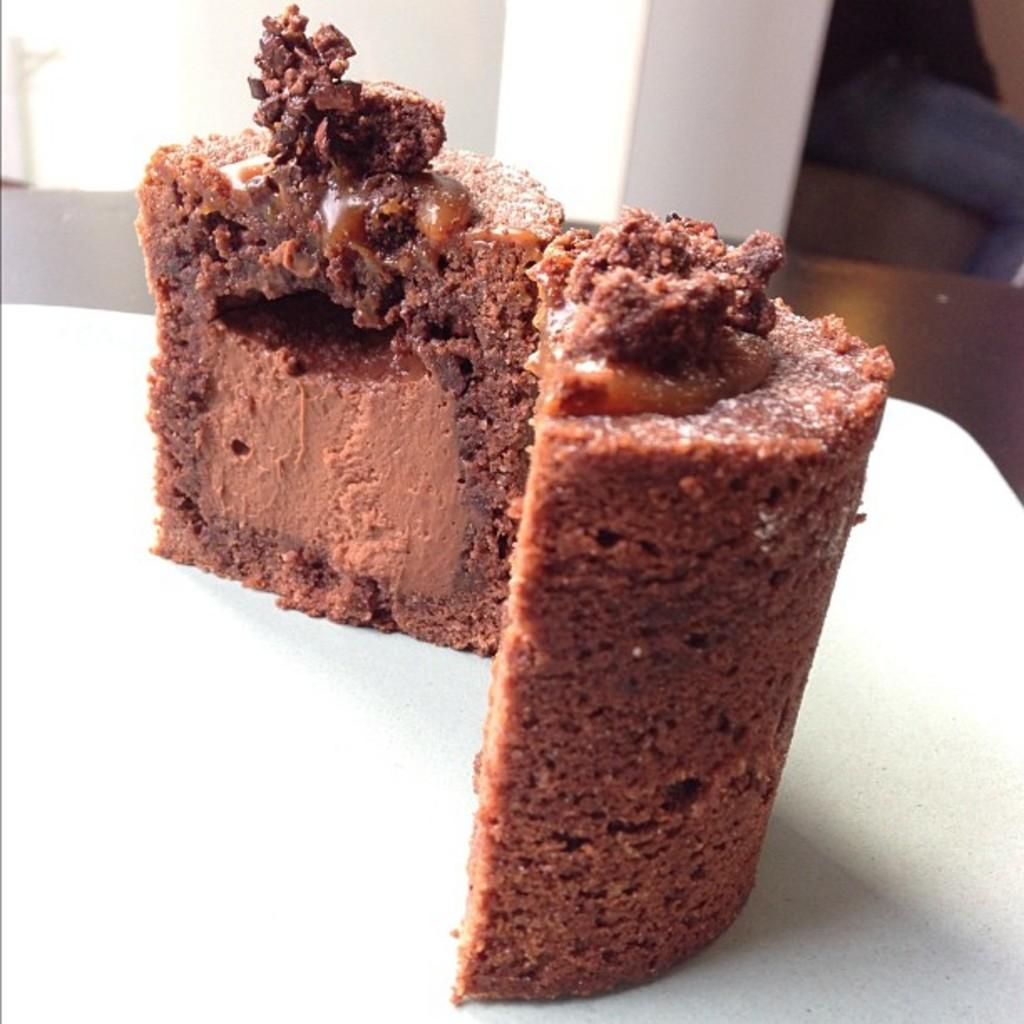What type of dessert is visible in the image? There is a slice of chocolate cake in the image. What is the cake placed on? The cake is on a white plate. Where is the plate located? The plate is placed on a surface. How would you describe the background of the image? The background of the image is slightly blurred. How many tomatoes are stacked on top of the word "record" in the image? There are no tomatoes or the word "record" present in the image. 